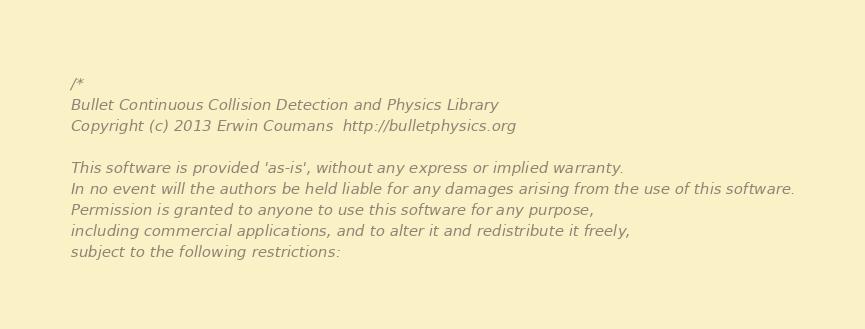<code> <loc_0><loc_0><loc_500><loc_500><_C++_>/*
Bullet Continuous Collision Detection and Physics Library
Copyright (c) 2013 Erwin Coumans  http://bulletphysics.org

This software is provided 'as-is', without any express or implied warranty.
In no event will the authors be held liable for any damages arising from the use of this software.
Permission is granted to anyone to use this software for any purpose,
including commercial applications, and to alter it and redistribute it freely,
subject to the following restrictions:
</code> 